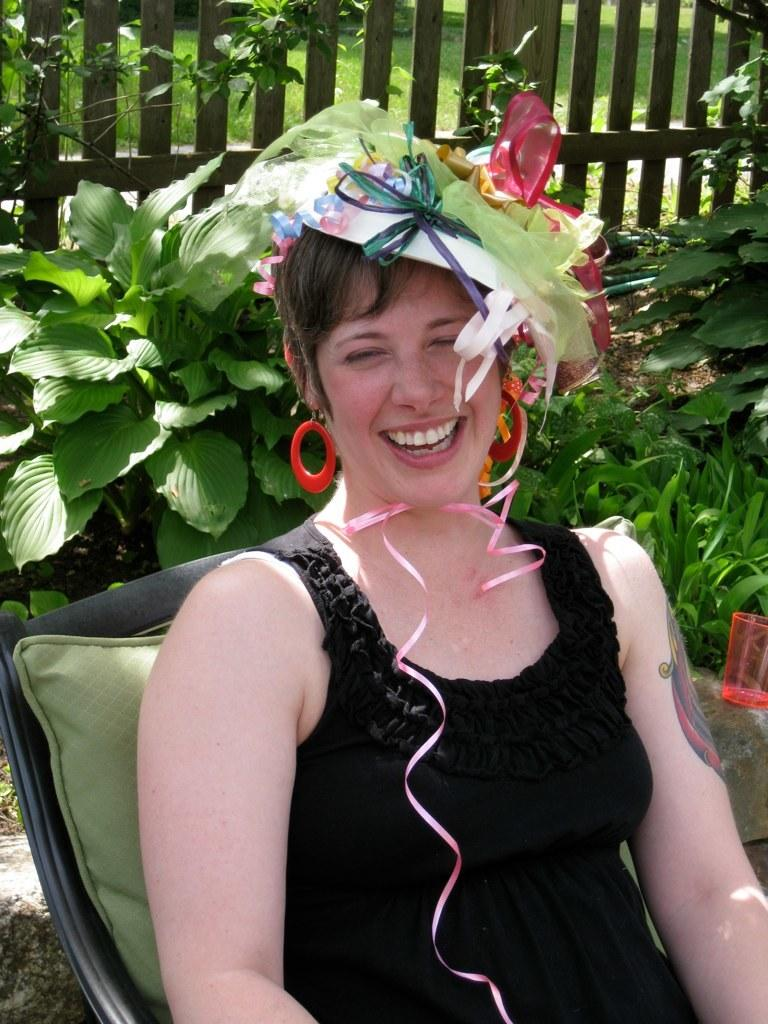What is the main subject of the image? There is a person in the image. What is the person wearing? The person is wearing a black dress. What is on the person's head? There is something on the person's head. What can be seen in the background of the image? There is fencing and plants in the background of the image. What is the rate of the bear's movement in the image? There is no bear present in the image, so it is not possible to determine the rate of its movement. 